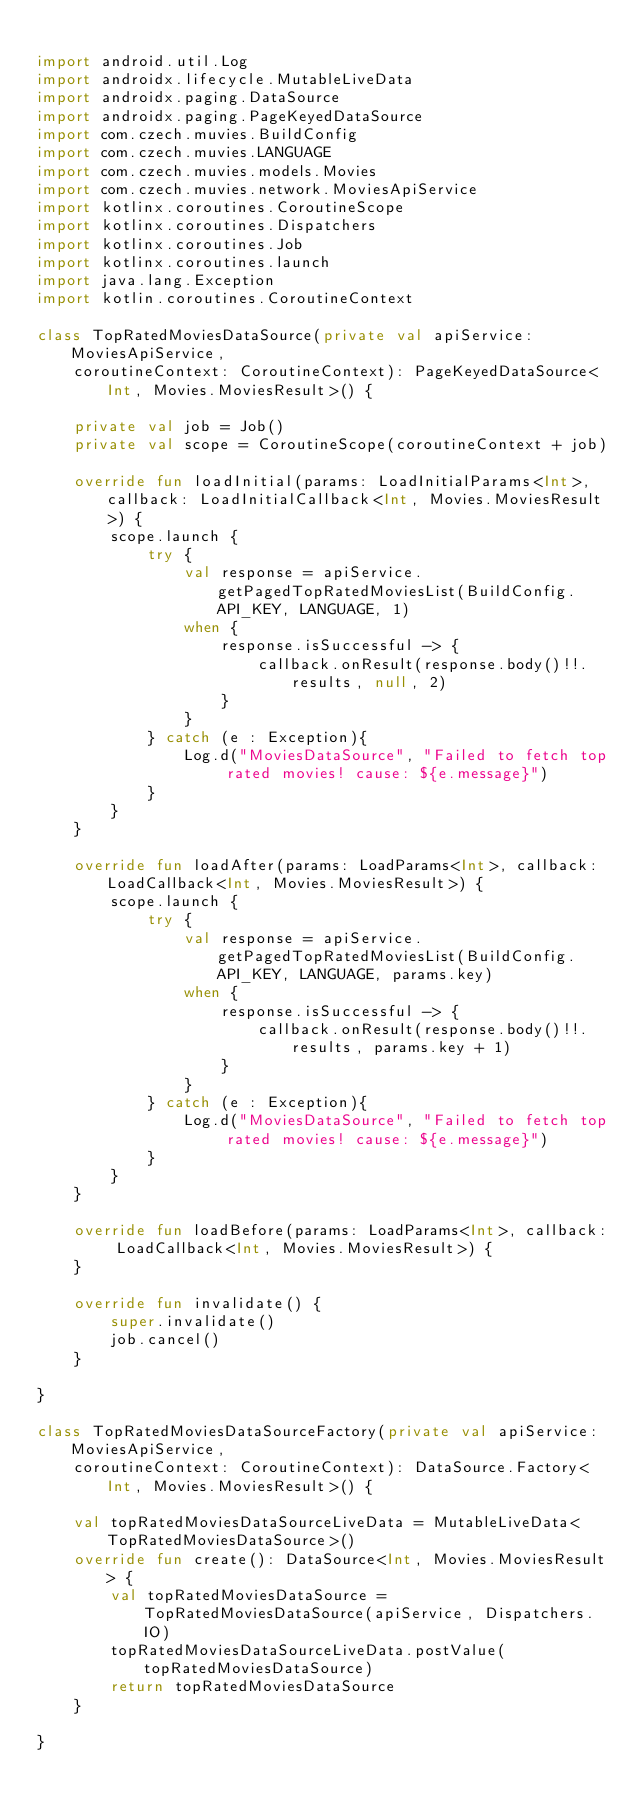<code> <loc_0><loc_0><loc_500><loc_500><_Kotlin_>
import android.util.Log
import androidx.lifecycle.MutableLiveData
import androidx.paging.DataSource
import androidx.paging.PageKeyedDataSource
import com.czech.muvies.BuildConfig
import com.czech.muvies.LANGUAGE
import com.czech.muvies.models.Movies
import com.czech.muvies.network.MoviesApiService
import kotlinx.coroutines.CoroutineScope
import kotlinx.coroutines.Dispatchers
import kotlinx.coroutines.Job
import kotlinx.coroutines.launch
import java.lang.Exception
import kotlin.coroutines.CoroutineContext

class TopRatedMoviesDataSource(private val apiService: MoviesApiService,
    coroutineContext: CoroutineContext): PageKeyedDataSource<Int, Movies.MoviesResult>() {

    private val job = Job()
    private val scope = CoroutineScope(coroutineContext + job)

    override fun loadInitial(params: LoadInitialParams<Int>, callback: LoadInitialCallback<Int, Movies.MoviesResult>) {
        scope.launch {
            try {
                val response = apiService.getPagedTopRatedMoviesList(BuildConfig.API_KEY, LANGUAGE, 1)
                when {
                    response.isSuccessful -> {
                        callback.onResult(response.body()!!.results, null, 2)
                    }
                }
            } catch (e : Exception){
                Log.d("MoviesDataSource", "Failed to fetch top rated movies! cause: ${e.message}")
            }
        }
    }

    override fun loadAfter(params: LoadParams<Int>, callback: LoadCallback<Int, Movies.MoviesResult>) {
        scope.launch {
            try {
                val response = apiService.getPagedTopRatedMoviesList(BuildConfig.API_KEY, LANGUAGE, params.key)
                when {
                    response.isSuccessful -> {
                        callback.onResult(response.body()!!.results, params.key + 1)
                    }
                }
            } catch (e : Exception){
                Log.d("MoviesDataSource", "Failed to fetch top rated movies! cause: ${e.message}")
            }
        }
    }

    override fun loadBefore(params: LoadParams<Int>, callback: LoadCallback<Int, Movies.MoviesResult>) {
    }

    override fun invalidate() {
        super.invalidate()
        job.cancel()
    }

}

class TopRatedMoviesDataSourceFactory(private val apiService: MoviesApiService,
    coroutineContext: CoroutineContext): DataSource.Factory<Int, Movies.MoviesResult>() {

    val topRatedMoviesDataSourceLiveData = MutableLiveData<TopRatedMoviesDataSource>()
    override fun create(): DataSource<Int, Movies.MoviesResult> {
        val topRatedMoviesDataSource = TopRatedMoviesDataSource(apiService, Dispatchers.IO)
        topRatedMoviesDataSourceLiveData.postValue(topRatedMoviesDataSource)
        return topRatedMoviesDataSource
    }

}</code> 